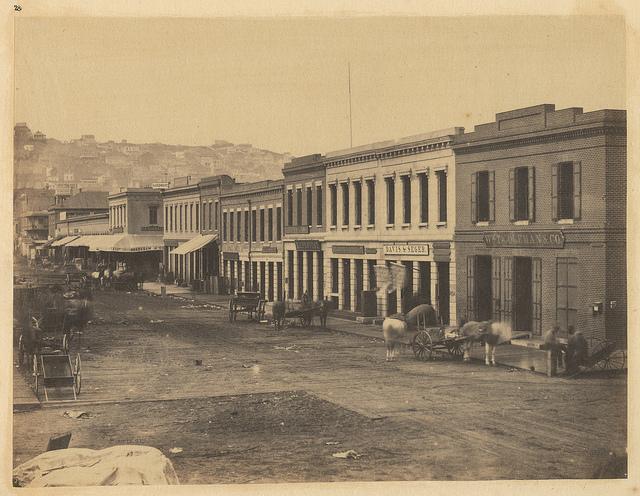Is this photo recent?
Answer briefly. No. Are there any people in the photo?
Be succinct. Yes. What color is the photo?
Concise answer only. Gray. 